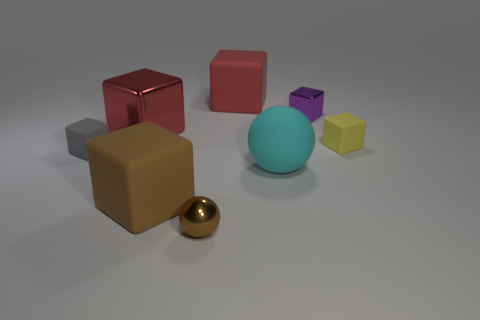Add 1 brown blocks. How many objects exist? 9 Subtract all small metallic blocks. How many blocks are left? 5 Subtract all cyan spheres. How many red blocks are left? 2 Subtract all purple blocks. How many blocks are left? 5 Subtract 2 blocks. How many blocks are left? 4 Subtract all cubes. How many objects are left? 2 Subtract all gray cubes. Subtract all cyan cylinders. How many cubes are left? 5 Subtract all purple metal things. Subtract all small metal objects. How many objects are left? 5 Add 6 tiny yellow things. How many tiny yellow things are left? 7 Add 7 brown blocks. How many brown blocks exist? 8 